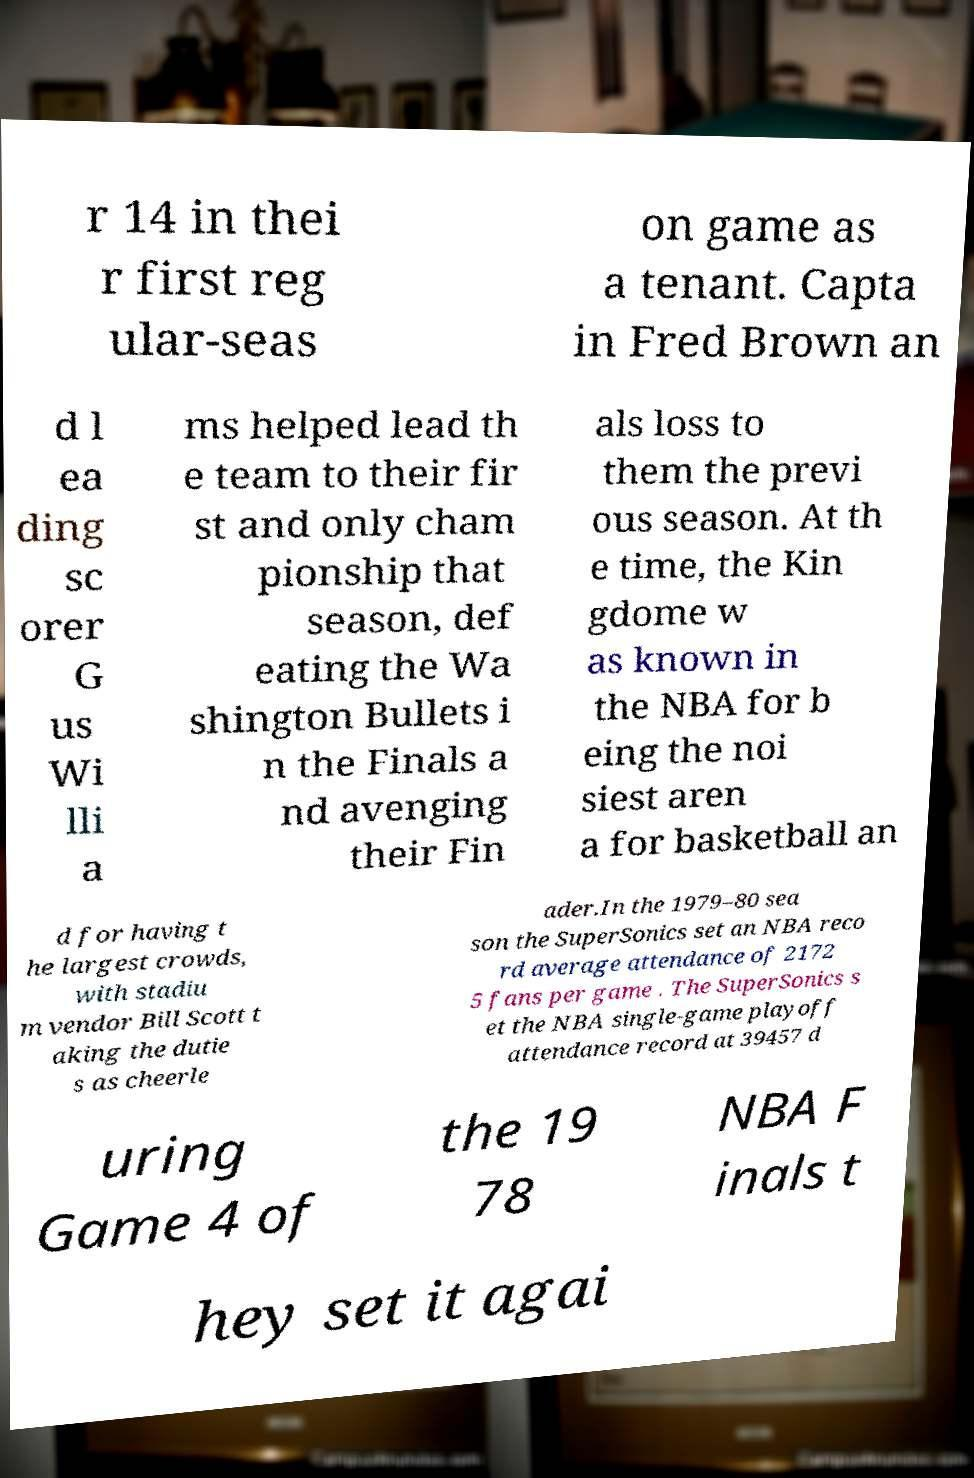Could you assist in decoding the text presented in this image and type it out clearly? r 14 in thei r first reg ular-seas on game as a tenant. Capta in Fred Brown an d l ea ding sc orer G us Wi lli a ms helped lead th e team to their fir st and only cham pionship that season, def eating the Wa shington Bullets i n the Finals a nd avenging their Fin als loss to them the previ ous season. At th e time, the Kin gdome w as known in the NBA for b eing the noi siest aren a for basketball an d for having t he largest crowds, with stadiu m vendor Bill Scott t aking the dutie s as cheerle ader.In the 1979–80 sea son the SuperSonics set an NBA reco rd average attendance of 2172 5 fans per game . The SuperSonics s et the NBA single-game playoff attendance record at 39457 d uring Game 4 of the 19 78 NBA F inals t hey set it agai 